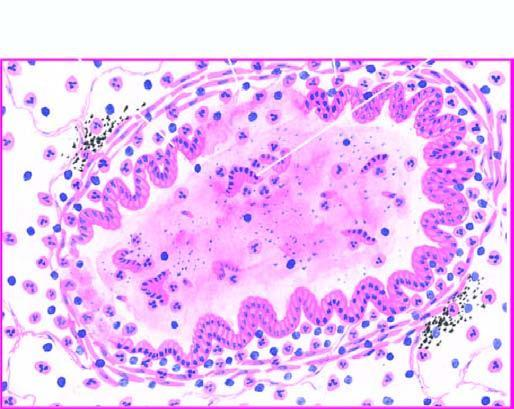what is the mucosa sloughed off at places with?
Answer the question using a single word or phrase. Exudate of muco-pus in the lumen 